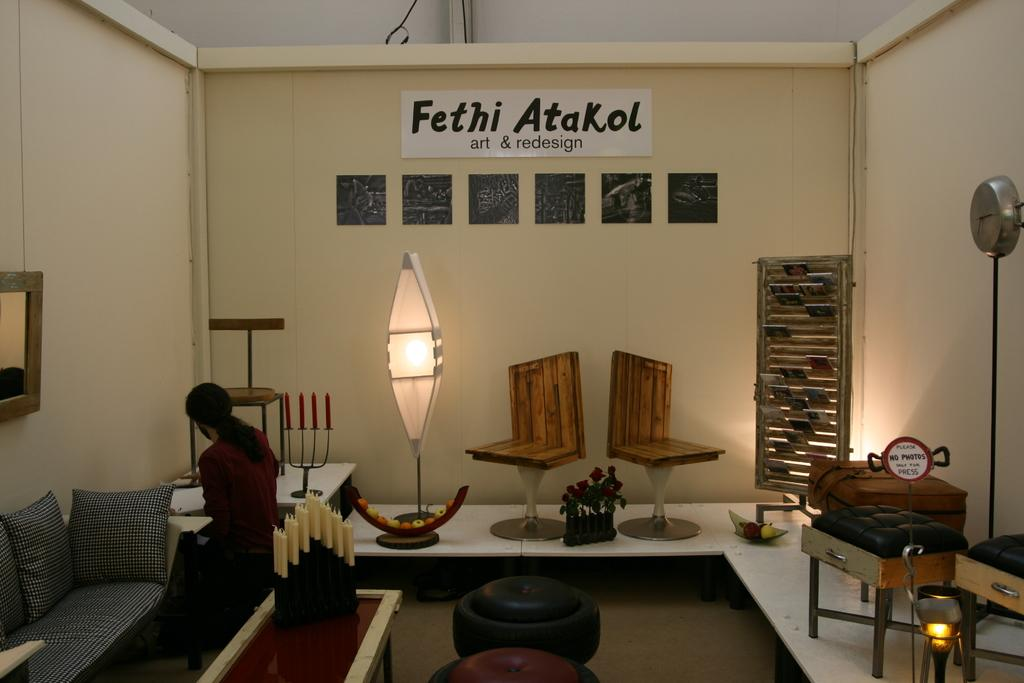<image>
Create a compact narrative representing the image presented. Large white banner that says "Fethi Atakol" hanging on top of a room. 